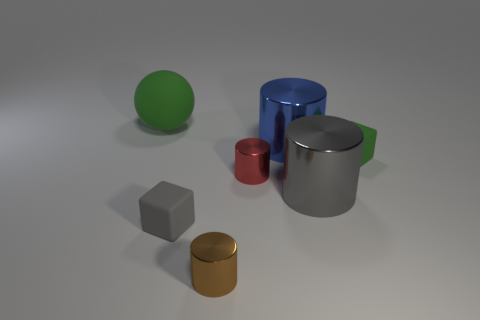What lighting conditions are depicted in the scene, and how do they affect the appearance of the objects? The lighting in the scene appears to be coming from above, casting soft shadows directly underneath the objects. This diffuse lighting condition highlights the shapes and textures of the objects, giving a matte finish to the surfaces and creating a calm, uniform look across the scene. 